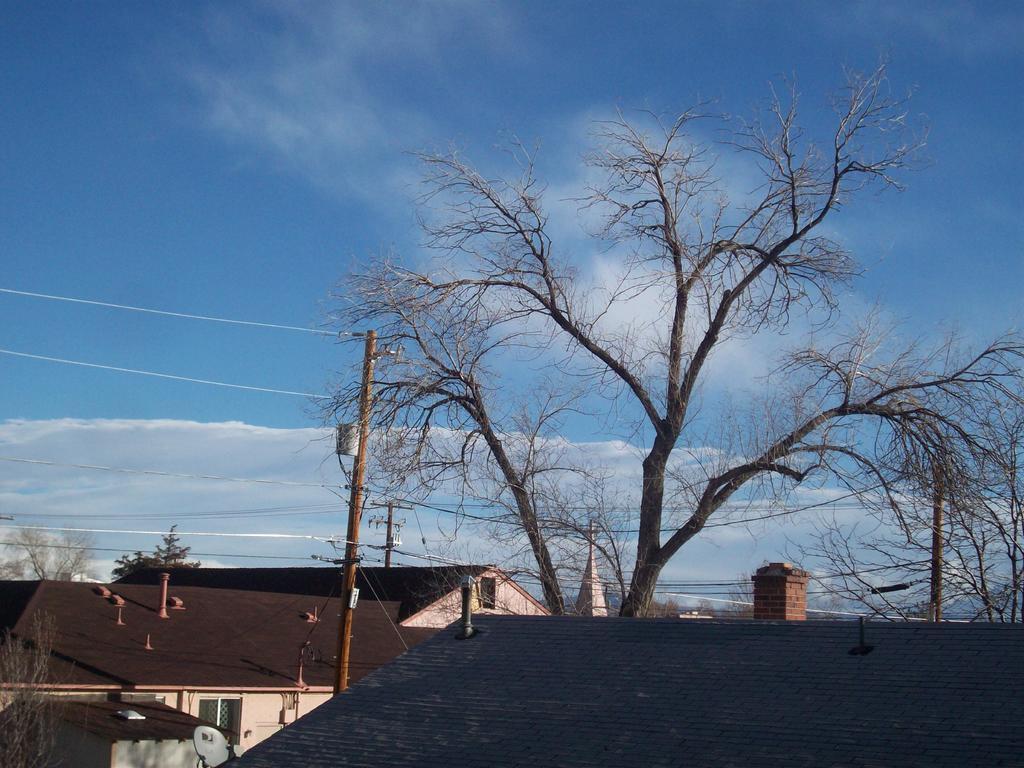In one or two sentences, can you explain what this image depicts? In this picture there are houses at the bottom side of the image and there is a tree in the center of the image. 